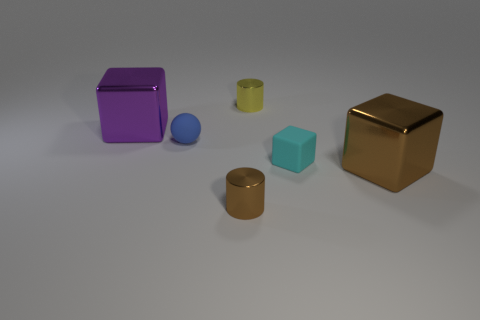Subtract all big metal blocks. How many blocks are left? 1 Subtract 1 cylinders. How many cylinders are left? 1 Add 2 green cylinders. How many objects exist? 8 Subtract all yellow cylinders. How many cylinders are left? 1 Add 1 large red rubber cubes. How many large red rubber cubes exist? 1 Subtract 0 yellow balls. How many objects are left? 6 Subtract all balls. How many objects are left? 5 Subtract all gray spheres. Subtract all brown cubes. How many spheres are left? 1 Subtract all cyan balls. How many gray cylinders are left? 0 Subtract all cyan things. Subtract all tiny cyan rubber blocks. How many objects are left? 4 